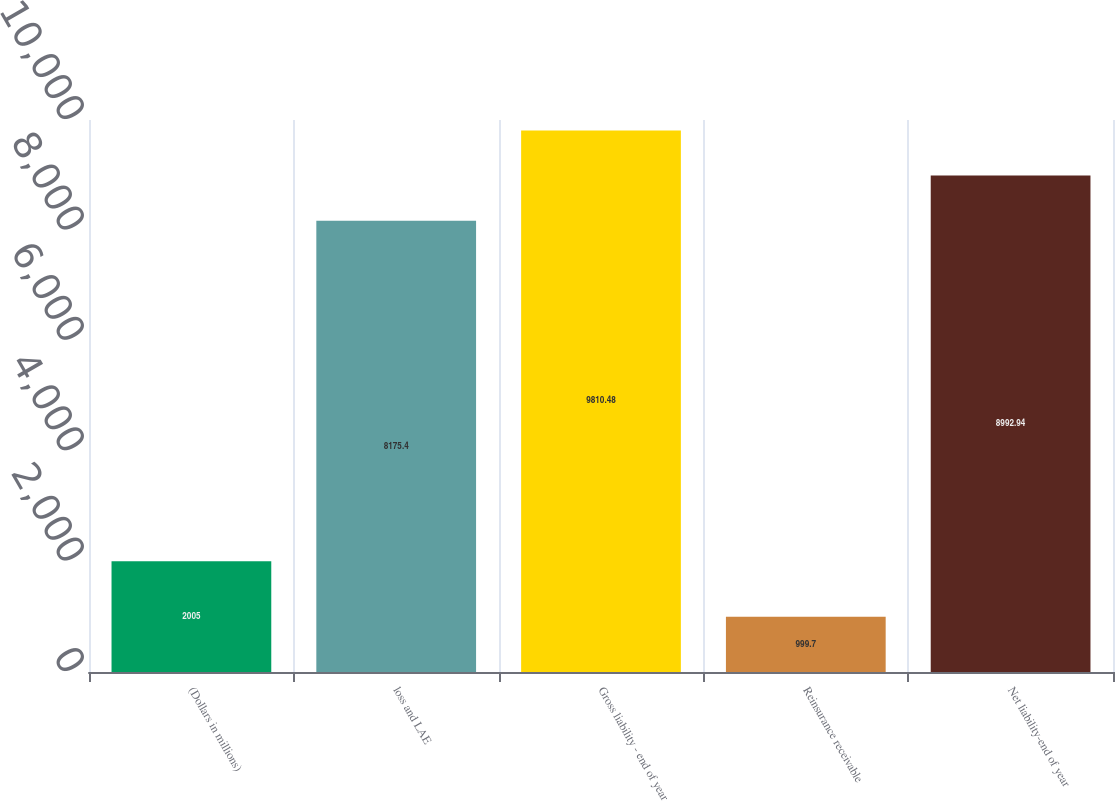Convert chart to OTSL. <chart><loc_0><loc_0><loc_500><loc_500><bar_chart><fcel>(Dollars in millions)<fcel>loss and LAE<fcel>Gross liability - end of year<fcel>Reinsurance receivable<fcel>Net liability-end of year<nl><fcel>2005<fcel>8175.4<fcel>9810.48<fcel>999.7<fcel>8992.94<nl></chart> 